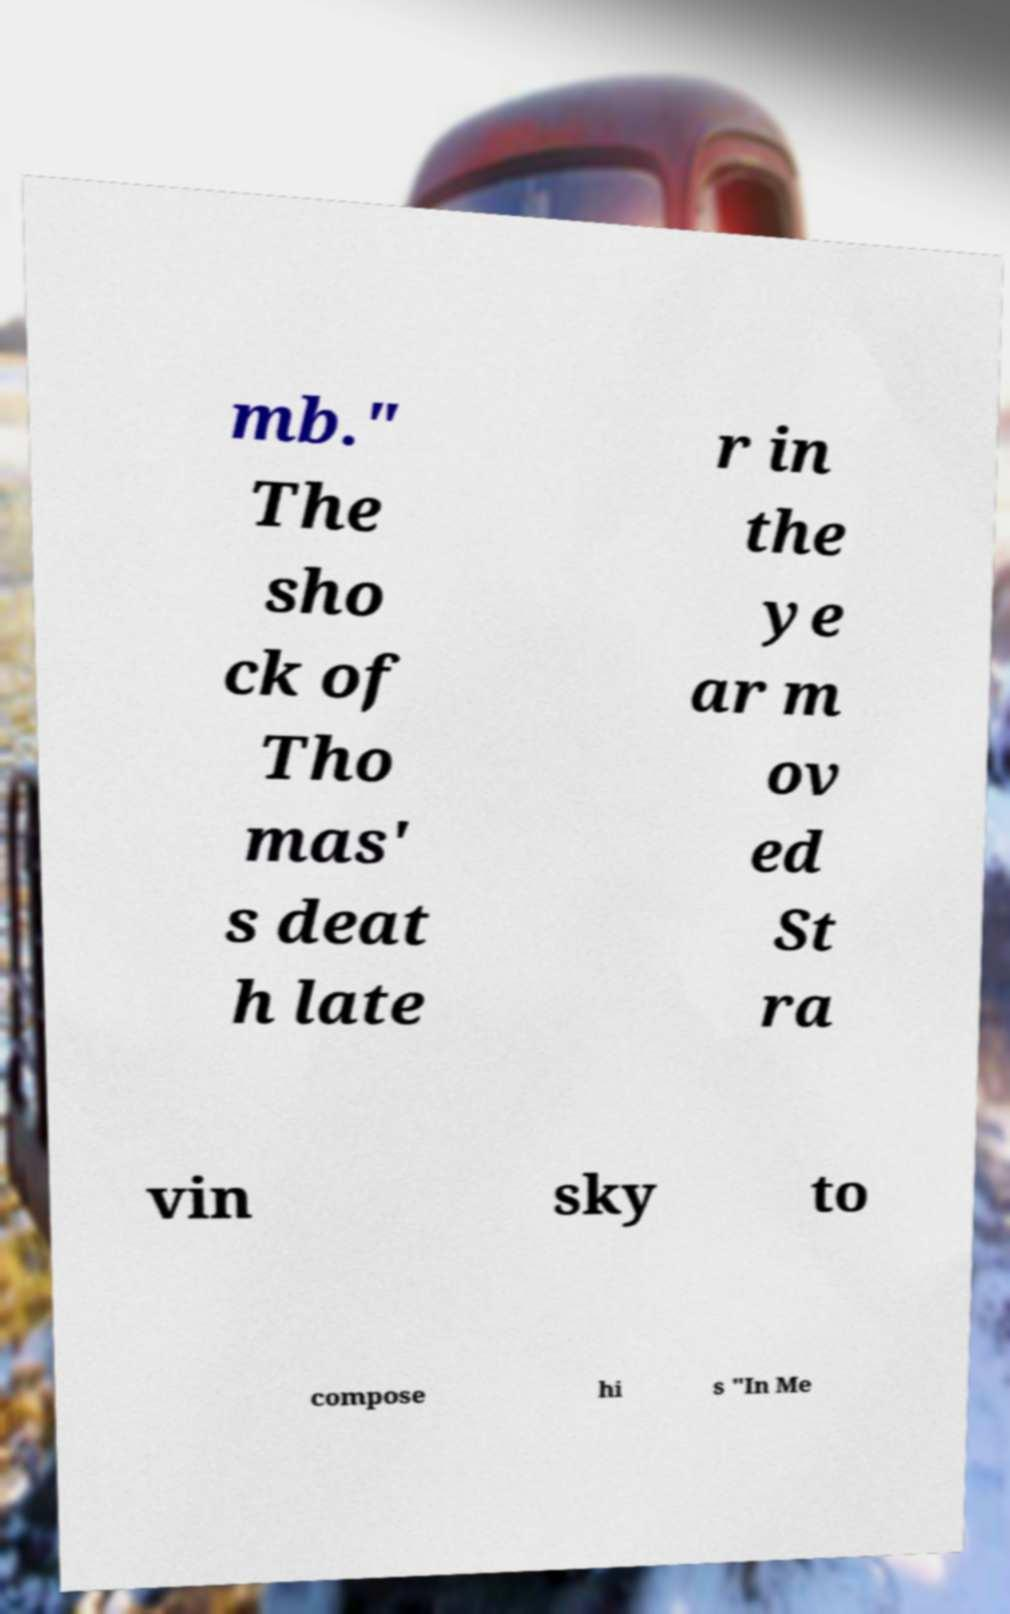Can you accurately transcribe the text from the provided image for me? mb." The sho ck of Tho mas' s deat h late r in the ye ar m ov ed St ra vin sky to compose hi s "In Me 